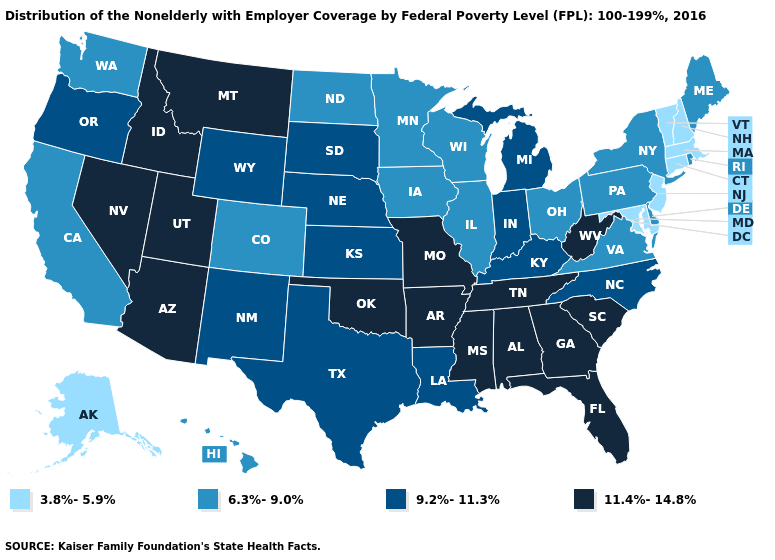Does the map have missing data?
Keep it brief. No. Which states hav the highest value in the MidWest?
Keep it brief. Missouri. Does Oklahoma have a higher value than Mississippi?
Give a very brief answer. No. Name the states that have a value in the range 9.2%-11.3%?
Short answer required. Indiana, Kansas, Kentucky, Louisiana, Michigan, Nebraska, New Mexico, North Carolina, Oregon, South Dakota, Texas, Wyoming. Does Alaska have the lowest value in the West?
Quick response, please. Yes. What is the highest value in the South ?
Give a very brief answer. 11.4%-14.8%. What is the highest value in the West ?
Short answer required. 11.4%-14.8%. Which states hav the highest value in the MidWest?
Write a very short answer. Missouri. Does Florida have the same value as Missouri?
Answer briefly. Yes. What is the value of Washington?
Keep it brief. 6.3%-9.0%. What is the highest value in the USA?
Be succinct. 11.4%-14.8%. What is the lowest value in the USA?
Short answer required. 3.8%-5.9%. Among the states that border Iowa , does Nebraska have the lowest value?
Answer briefly. No. How many symbols are there in the legend?
Quick response, please. 4. 